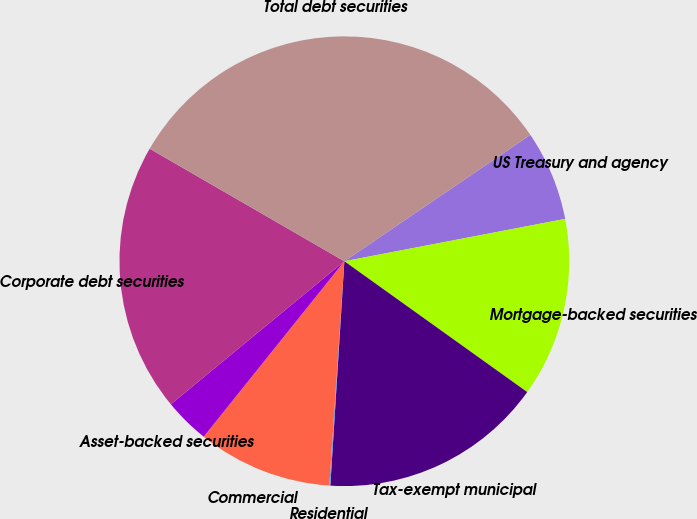Convert chart to OTSL. <chart><loc_0><loc_0><loc_500><loc_500><pie_chart><fcel>US Treasury and agency<fcel>Mortgage-backed securities<fcel>Tax-exempt municipal<fcel>Residential<fcel>Commercial<fcel>Asset-backed securities<fcel>Corporate debt securities<fcel>Total debt securities<nl><fcel>6.48%<fcel>12.9%<fcel>16.11%<fcel>0.07%<fcel>9.69%<fcel>3.27%<fcel>19.32%<fcel>32.16%<nl></chart> 